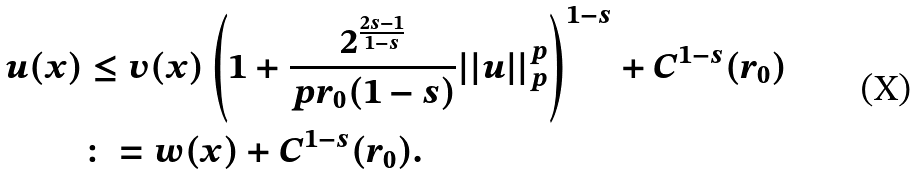Convert formula to latex. <formula><loc_0><loc_0><loc_500><loc_500>u ( x ) & \leq v ( x ) \left ( 1 + \frac { 2 ^ { \frac { 2 s - 1 } { 1 - s } } } { p r _ { 0 } ( 1 - s ) } | | u | | _ { p } ^ { p } \right ) ^ { 1 - s } + C ^ { 1 - s } ( r _ { 0 } ) \\ & \colon = w ( x ) + C ^ { 1 - s } ( r _ { 0 } ) .</formula> 